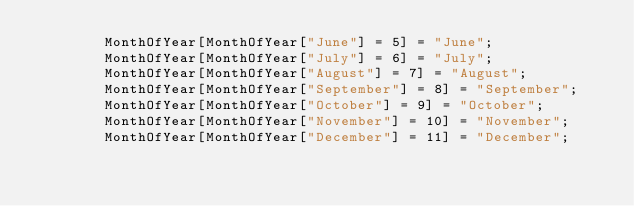Convert code to text. <code><loc_0><loc_0><loc_500><loc_500><_JavaScript_>        MonthOfYear[MonthOfYear["June"] = 5] = "June";
        MonthOfYear[MonthOfYear["July"] = 6] = "July";
        MonthOfYear[MonthOfYear["August"] = 7] = "August";
        MonthOfYear[MonthOfYear["September"] = 8] = "September";
        MonthOfYear[MonthOfYear["October"] = 9] = "October";
        MonthOfYear[MonthOfYear["November"] = 10] = "November";
        MonthOfYear[MonthOfYear["December"] = 11] = "December";</code> 